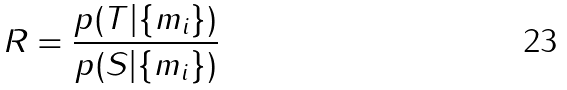Convert formula to latex. <formula><loc_0><loc_0><loc_500><loc_500>R = \frac { p ( T | \{ m _ { i } \} ) } { p ( S | \{ m _ { i } \} ) }</formula> 